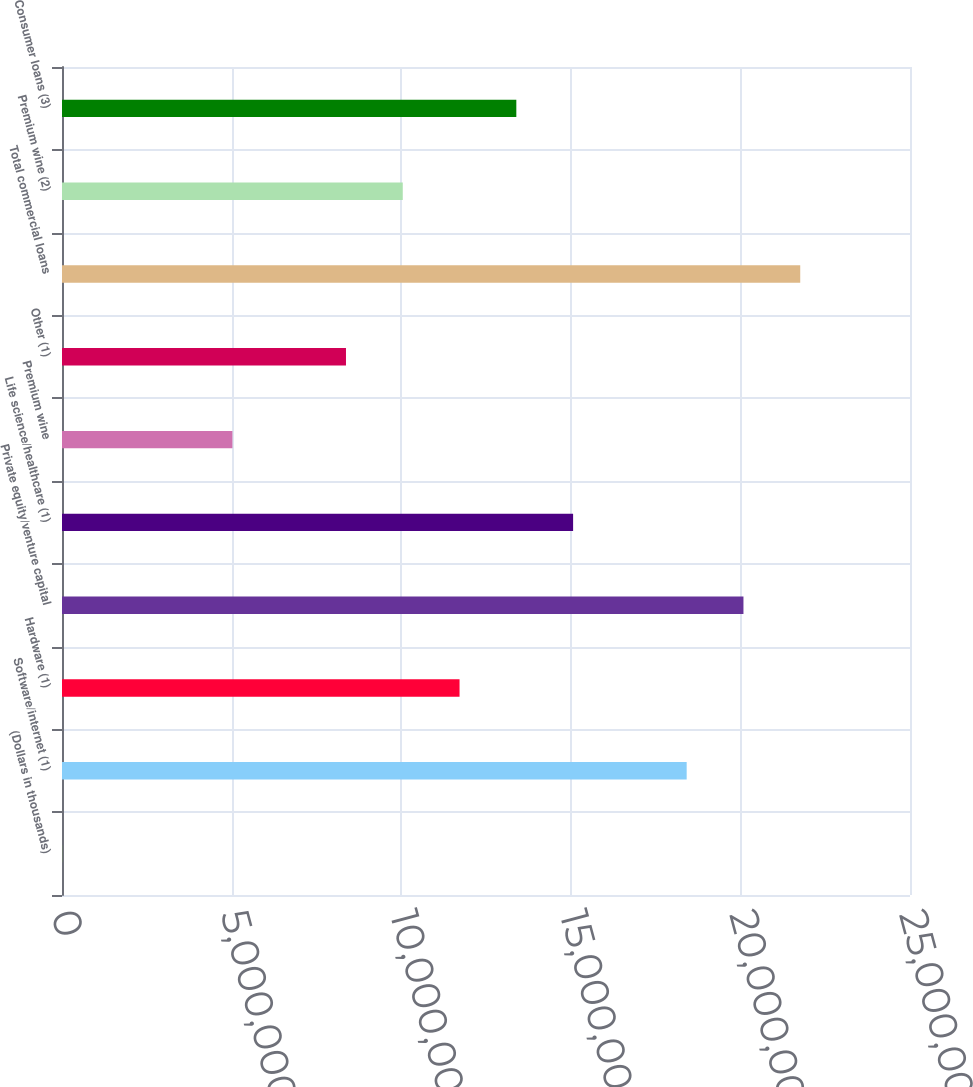Convert chart. <chart><loc_0><loc_0><loc_500><loc_500><bar_chart><fcel>(Dollars in thousands)<fcel>Software/internet (1)<fcel>Hardware (1)<fcel>Private equity/venture capital<fcel>Life science/healthcare (1)<fcel>Premium wine<fcel>Other (1)<fcel>Total commercial loans<fcel>Premium wine (2)<fcel>Consumer loans (3)<nl><fcel>2015<fcel>1.84161e+07<fcel>1.17201e+07<fcel>2.00901e+07<fcel>1.50681e+07<fcel>5.02403e+06<fcel>8.37204e+06<fcel>2.17641e+07<fcel>1.0046e+07<fcel>1.33941e+07<nl></chart> 